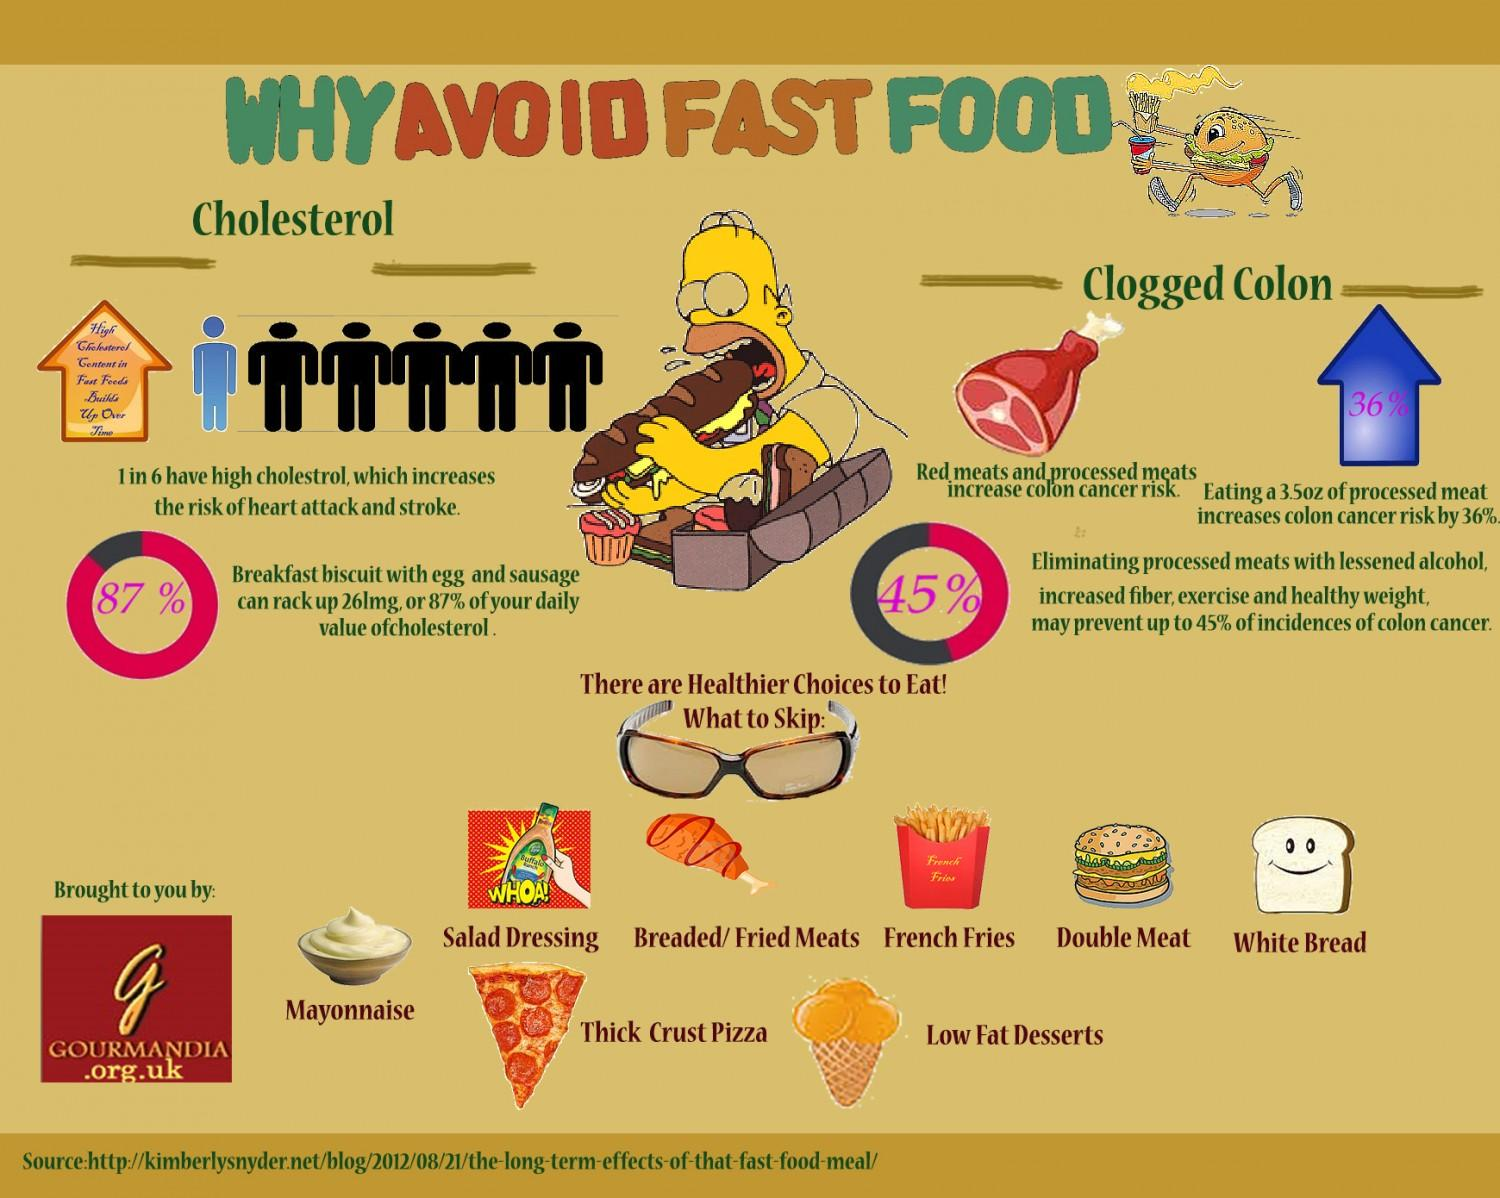Indicate a few pertinent items in this graphic. Fast food consumption can increase the risk of high cholesterol levels and clogged colon, two significant health concerns. High cholesterol content in fast foods can accumulate over time and have negative health consequences. The chicken leg indicates the consumption of breaded/fried meats as a type of food. The color of the bread is white or brown. In my opinion, the bread is white. The text "What is written inside the blue arrow? 36%" is a question asking for information about a specific point or item referenced by the blue arrow. 